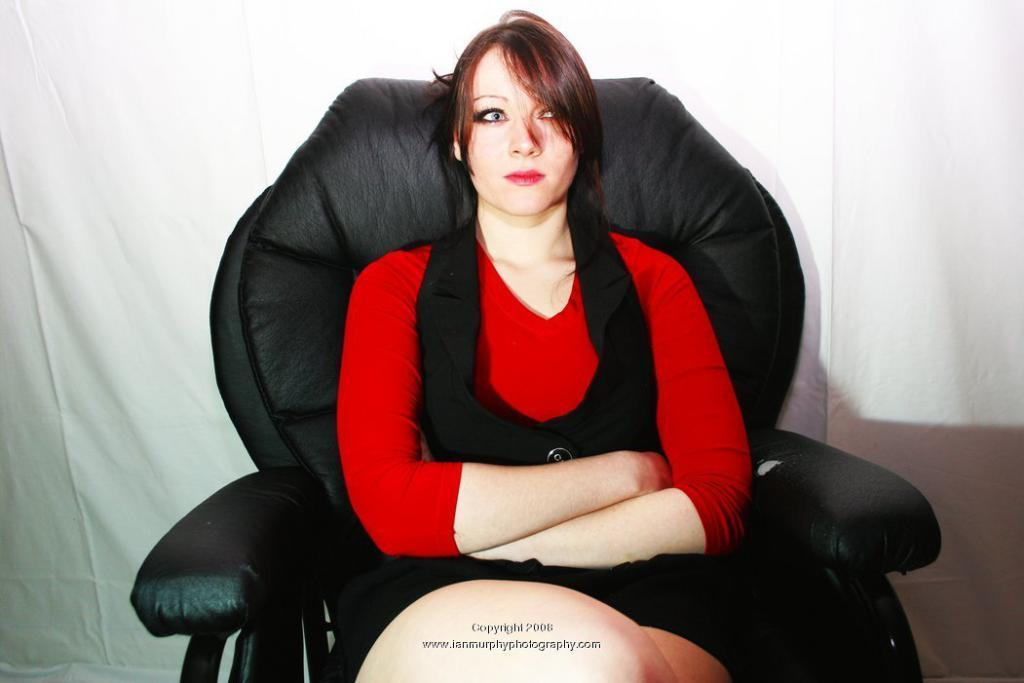Who is the main subject in the image? There is a woman in the image. What is the woman doing in the image? The woman is sitting in a chair and folding her hands. What type of sweater is the woman wearing in the image? The image does not show the woman wearing a sweater, so it cannot be determined from the image. 